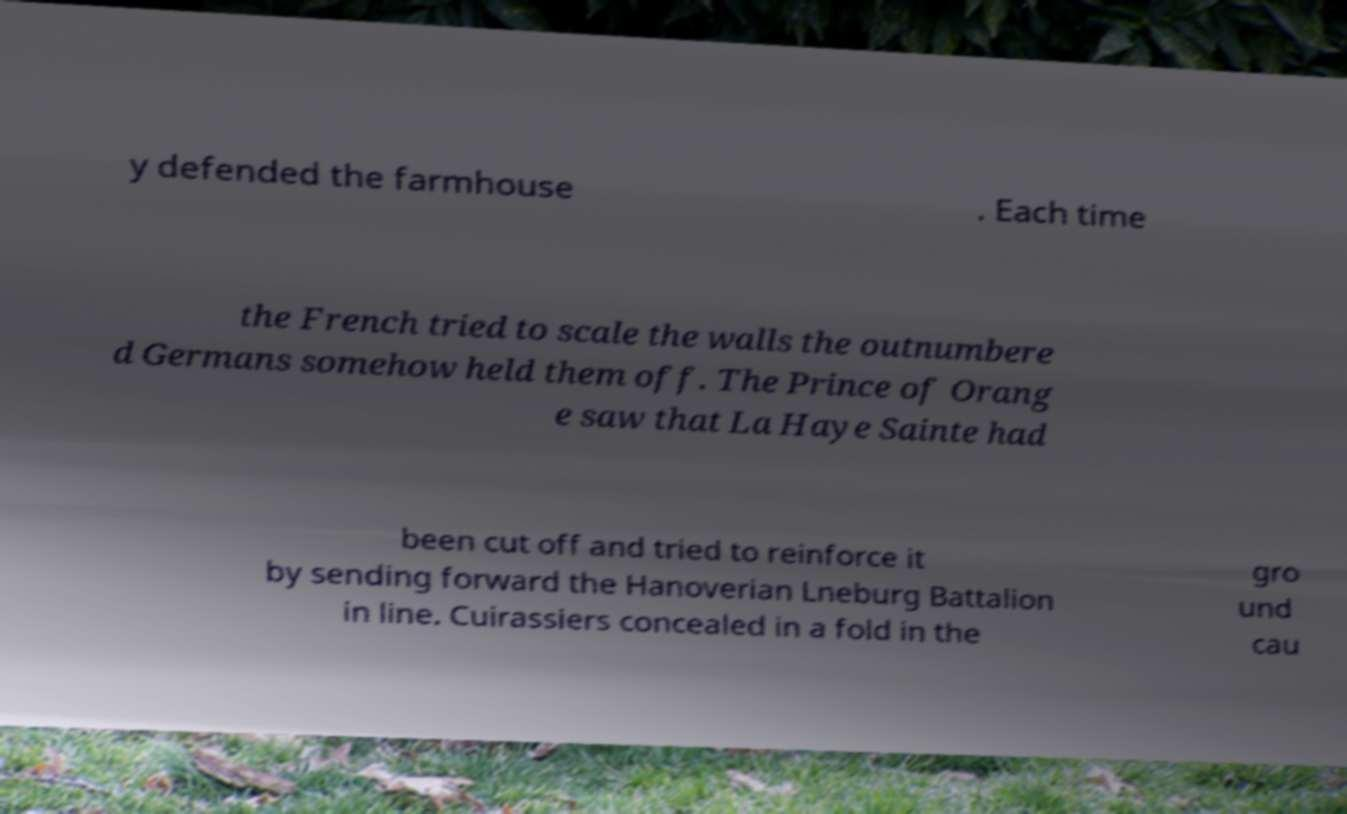Please read and relay the text visible in this image. What does it say? y defended the farmhouse . Each time the French tried to scale the walls the outnumbere d Germans somehow held them off. The Prince of Orang e saw that La Haye Sainte had been cut off and tried to reinforce it by sending forward the Hanoverian Lneburg Battalion in line. Cuirassiers concealed in a fold in the gro und cau 